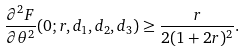Convert formula to latex. <formula><loc_0><loc_0><loc_500><loc_500>\frac { \partial ^ { 2 } F } { \partial \theta ^ { 2 } } ( 0 ; r , d _ { 1 } , d _ { 2 } , d _ { 3 } ) \geq \frac { r } { 2 ( 1 + 2 r ) ^ { 2 } } .</formula> 